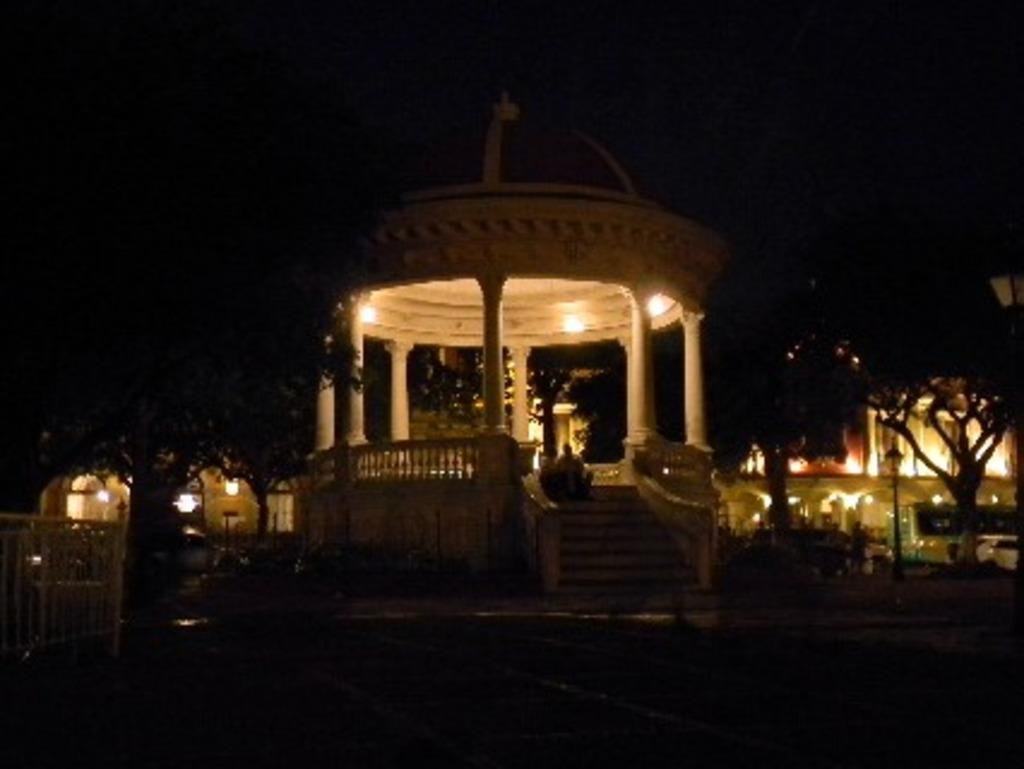What is the overall lighting condition in the image? The image is dark. Can you identify any people in the image? Yes, there are people in the image. What architectural features are present in the image? There are pillars, a railing, steps, a pole, and a fence in the image. Are there any natural elements visible in the image? Yes, there are trees in the image. What is visible in the background of the image? Vehicles and lights are visible in the background of the image. What type of silk fabric is draped over the carriage in the image? There is no carriage or silk fabric present in the image. Is the image showing any motion or movement? The image itself is static, and there is no indication of motion or movement within the scene. 